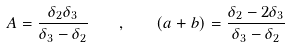Convert formula to latex. <formula><loc_0><loc_0><loc_500><loc_500>A = \frac { \delta _ { 2 } \delta _ { 3 } } { \delta _ { 3 } - \delta _ { 2 } } \quad , \quad ( a + b ) = \frac { \delta _ { 2 } - 2 \delta _ { 3 } } { \delta _ { 3 } - \delta _ { 2 } }</formula> 